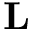Convert formula to latex. <formula><loc_0><loc_0><loc_500><loc_500>L</formula> 